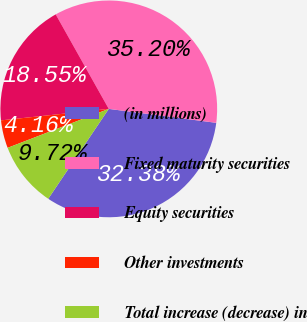Convert chart. <chart><loc_0><loc_0><loc_500><loc_500><pie_chart><fcel>(in millions)<fcel>Fixed maturity securities<fcel>Equity securities<fcel>Other investments<fcel>Total increase (decrease) in<nl><fcel>32.38%<fcel>35.2%<fcel>18.55%<fcel>4.16%<fcel>9.72%<nl></chart> 